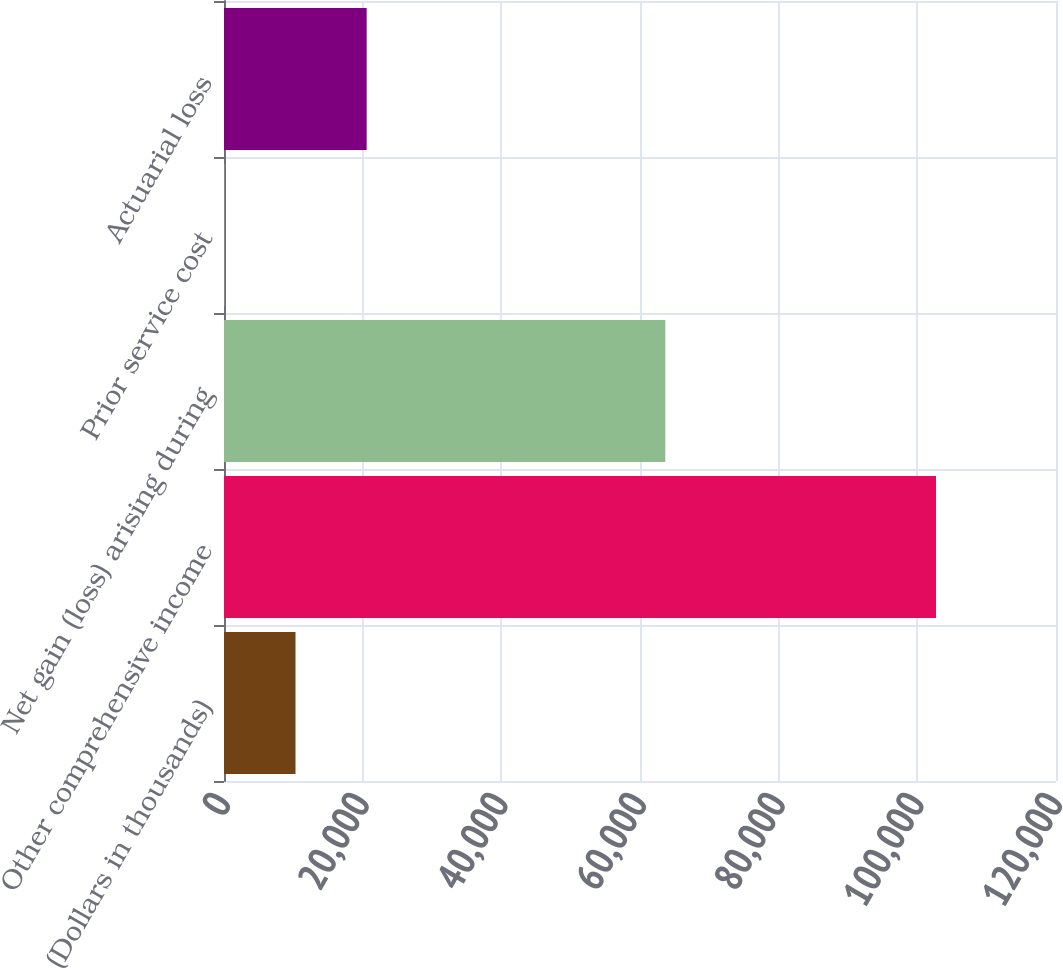Convert chart. <chart><loc_0><loc_0><loc_500><loc_500><bar_chart><fcel>(Dollars in thousands)<fcel>Other comprehensive income<fcel>Net gain (loss) arising during<fcel>Prior service cost<fcel>Actuarial loss<nl><fcel>10313.3<fcel>102692<fcel>63651.3<fcel>49<fcel>20577.6<nl></chart> 